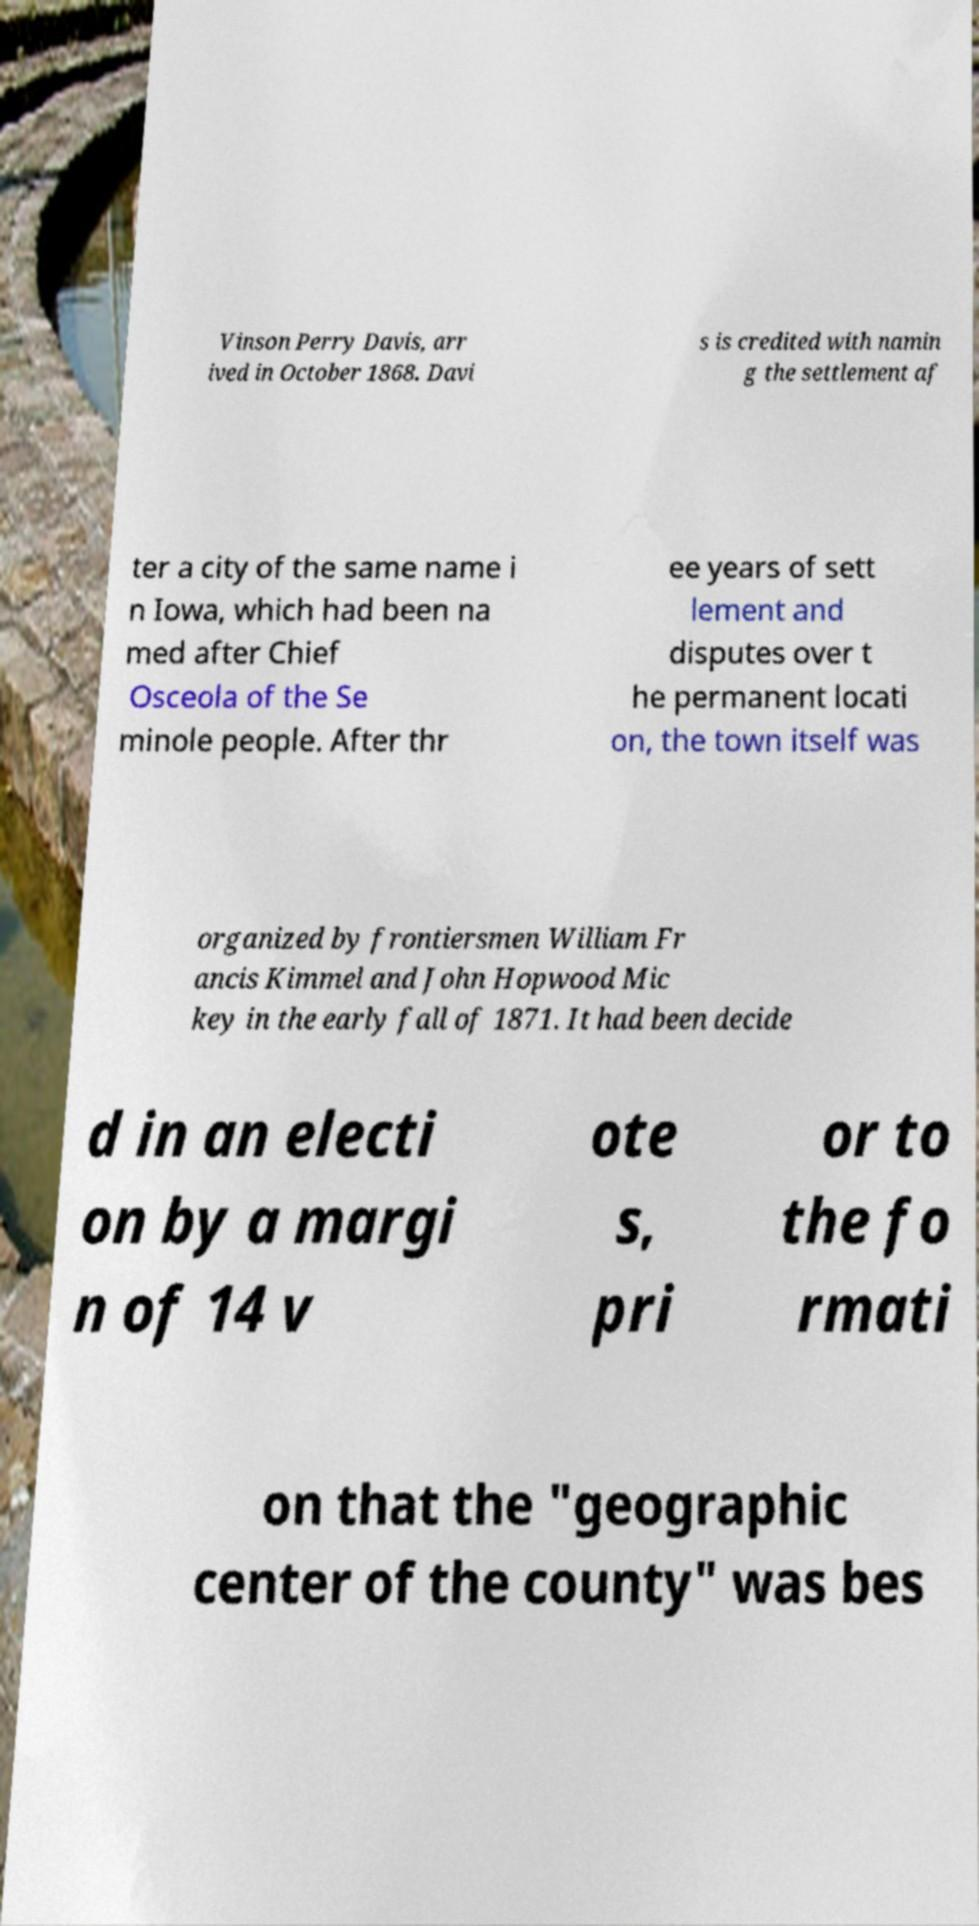There's text embedded in this image that I need extracted. Can you transcribe it verbatim? Vinson Perry Davis, arr ived in October 1868. Davi s is credited with namin g the settlement af ter a city of the same name i n Iowa, which had been na med after Chief Osceola of the Se minole people. After thr ee years of sett lement and disputes over t he permanent locati on, the town itself was organized by frontiersmen William Fr ancis Kimmel and John Hopwood Mic key in the early fall of 1871. It had been decide d in an electi on by a margi n of 14 v ote s, pri or to the fo rmati on that the "geographic center of the county" was bes 